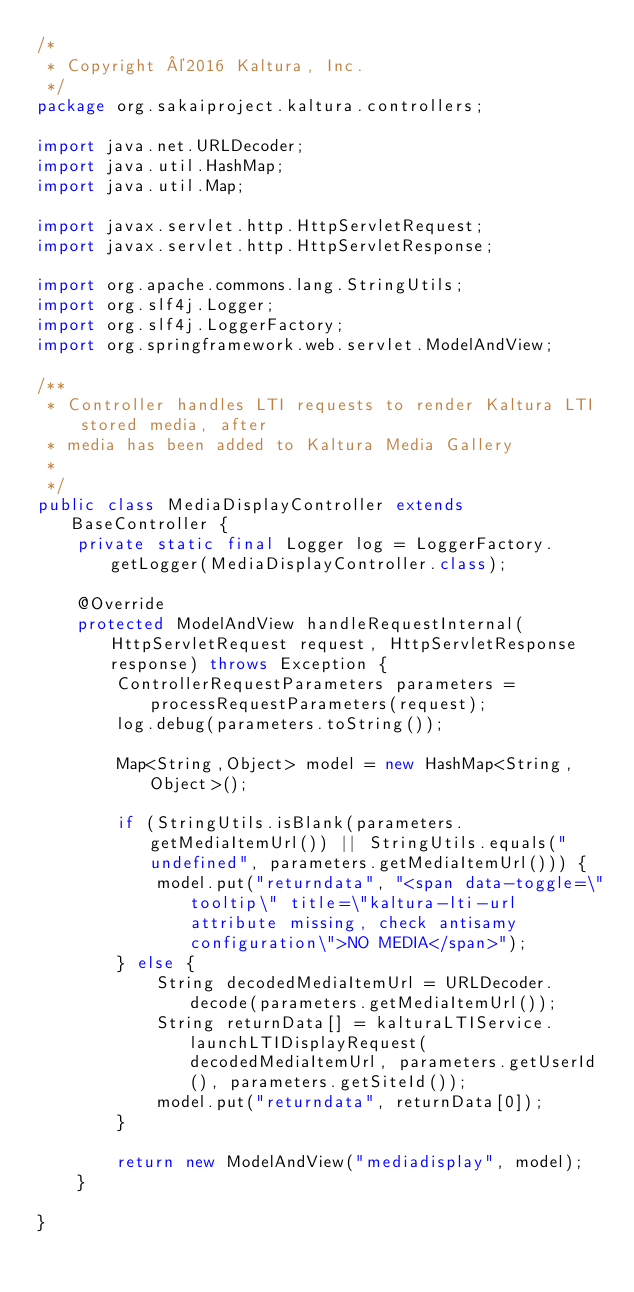<code> <loc_0><loc_0><loc_500><loc_500><_Java_>/*
 * Copyright ©2016 Kaltura, Inc.
 */
package org.sakaiproject.kaltura.controllers;

import java.net.URLDecoder;
import java.util.HashMap;
import java.util.Map;

import javax.servlet.http.HttpServletRequest;
import javax.servlet.http.HttpServletResponse;

import org.apache.commons.lang.StringUtils;
import org.slf4j.Logger;
import org.slf4j.LoggerFactory;
import org.springframework.web.servlet.ModelAndView;

/**
 * Controller handles LTI requests to render Kaltura LTI stored media, after
 * media has been added to Kaltura Media Gallery
 *
 */
public class MediaDisplayController extends BaseController {
    private static final Logger log = LoggerFactory.getLogger(MediaDisplayController.class);

    @Override
    protected ModelAndView handleRequestInternal(HttpServletRequest request, HttpServletResponse response) throws Exception {
        ControllerRequestParameters parameters = processRequestParameters(request);
        log.debug(parameters.toString());

        Map<String,Object> model = new HashMap<String,Object>();

        if (StringUtils.isBlank(parameters.getMediaItemUrl()) || StringUtils.equals("undefined", parameters.getMediaItemUrl())) {
            model.put("returndata", "<span data-toggle=\"tooltip\" title=\"kaltura-lti-url attribute missing, check antisamy configuration\">NO MEDIA</span>");
        } else {
            String decodedMediaItemUrl = URLDecoder.decode(parameters.getMediaItemUrl());
            String returnData[] = kalturaLTIService.launchLTIDisplayRequest(decodedMediaItemUrl, parameters.getUserId(), parameters.getSiteId());
            model.put("returndata", returnData[0]);
        }

        return new ModelAndView("mediadisplay", model);
    }

}
</code> 